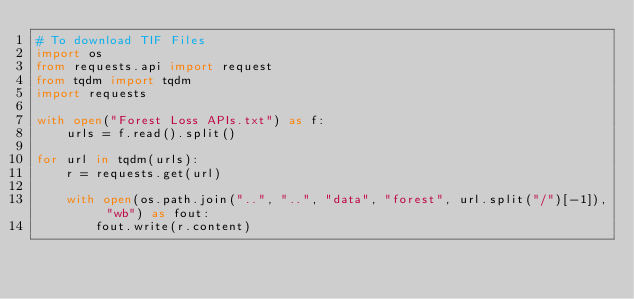Convert code to text. <code><loc_0><loc_0><loc_500><loc_500><_Python_># To download TIF Files
import os
from requests.api import request
from tqdm import tqdm
import requests

with open("Forest Loss APIs.txt") as f:
    urls = f.read().split()

for url in tqdm(urls):
    r = requests.get(url)

    with open(os.path.join("..", "..", "data", "forest", url.split("/")[-1]), "wb") as fout:
        fout.write(r.content)</code> 